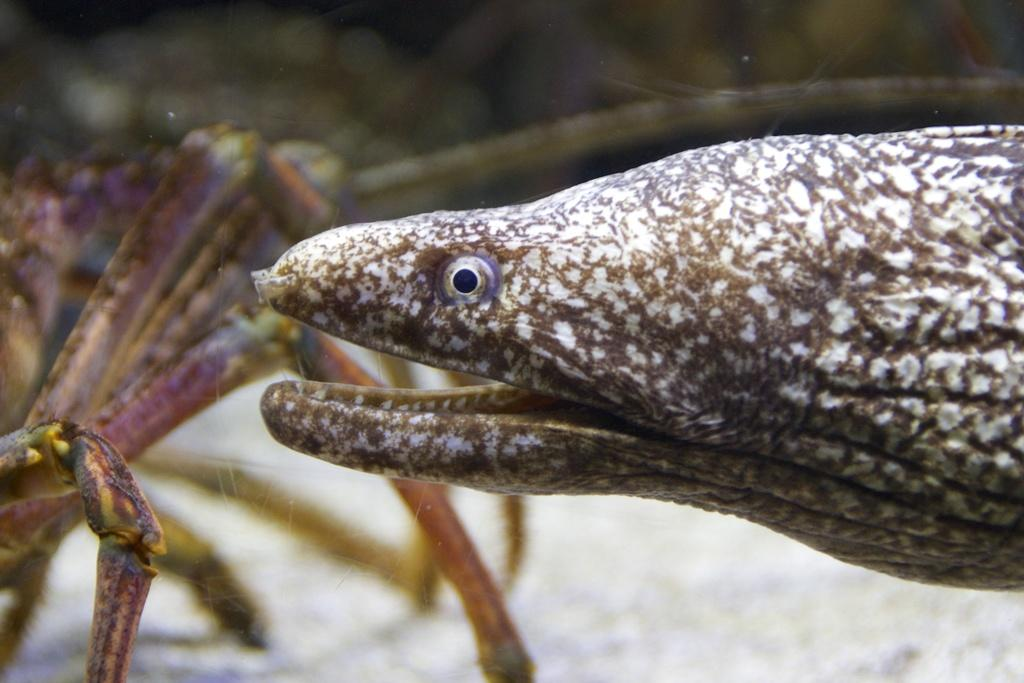What type of living organisms are present in the image? There are animals in the image. What are the basic features of the animals' faces? The animals have eyes and mouths. Can you describe the object on the left side of the image? There is a spider-like object on the left side of the image. How many passengers are on the animal's back in the image? There are no passengers present on any animal's back in the image. What type of leg is visible on the animal in the image? There is no specific leg mentioned or visible in the image; only the animals' eyes and mouths are described. 